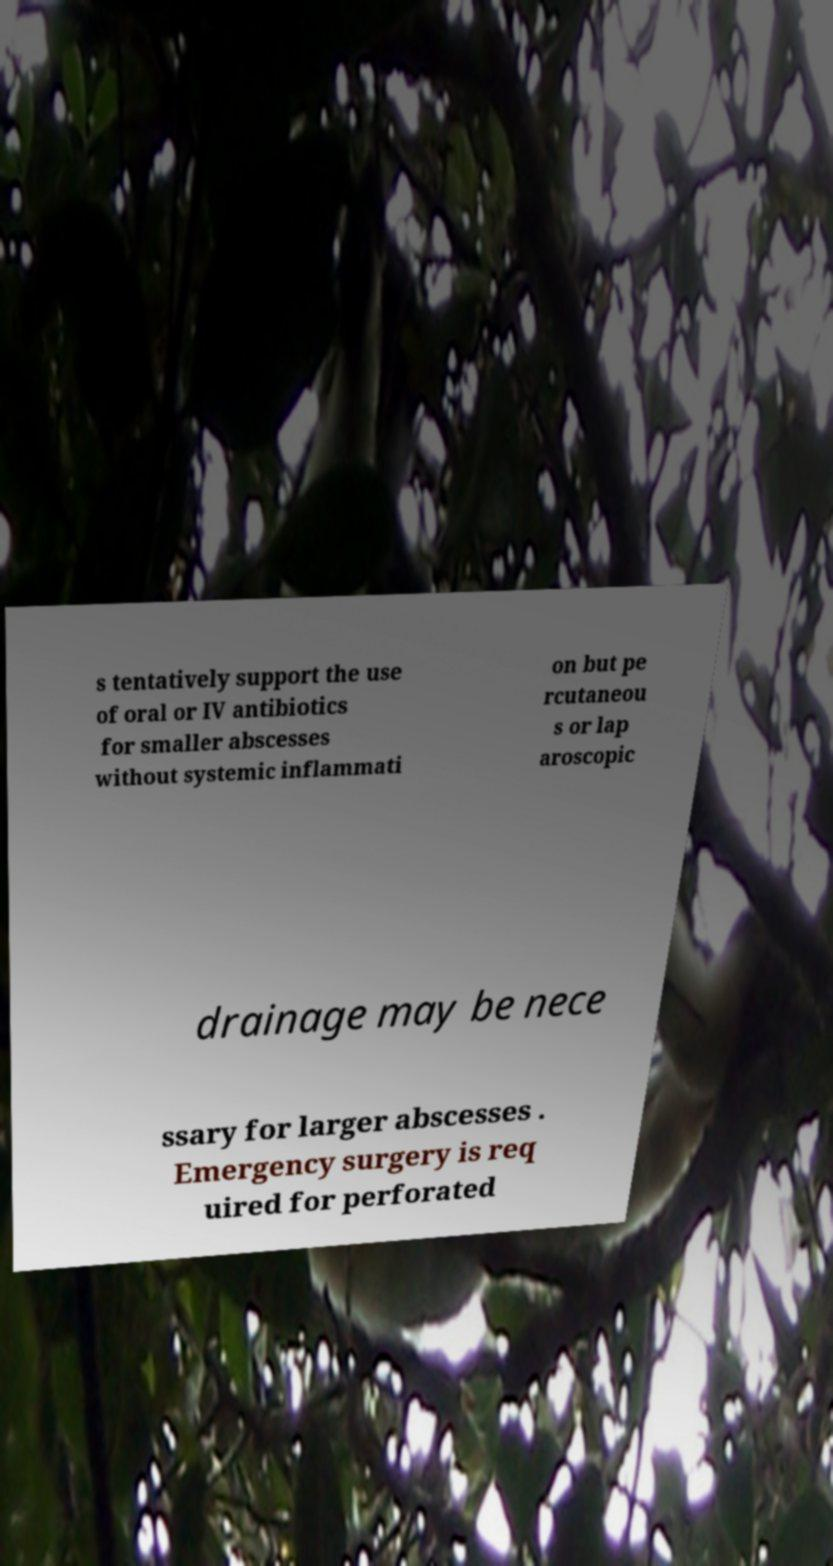Can you read and provide the text displayed in the image?This photo seems to have some interesting text. Can you extract and type it out for me? s tentatively support the use of oral or IV antibiotics for smaller abscesses without systemic inflammati on but pe rcutaneou s or lap aroscopic drainage may be nece ssary for larger abscesses . Emergency surgery is req uired for perforated 